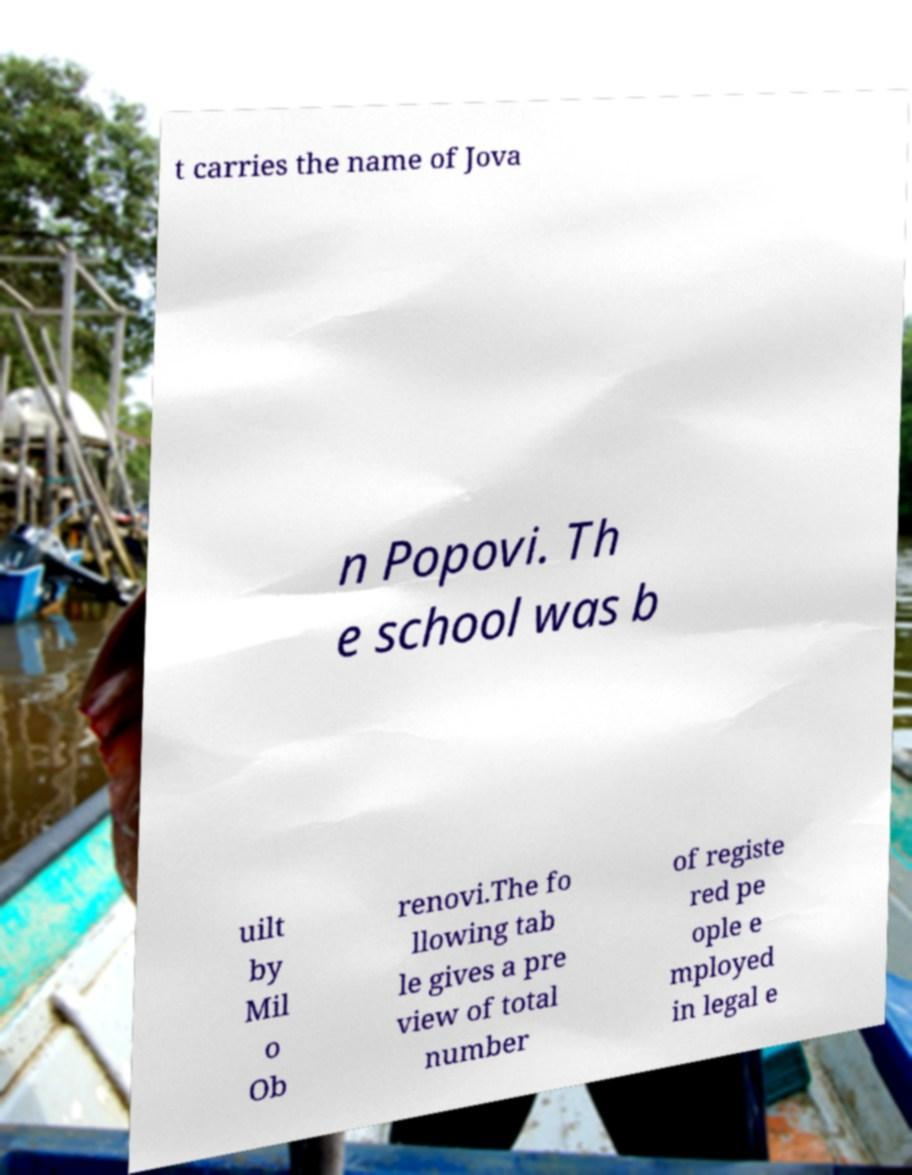I need the written content from this picture converted into text. Can you do that? t carries the name of Jova n Popovi. Th e school was b uilt by Mil o Ob renovi.The fo llowing tab le gives a pre view of total number of registe red pe ople e mployed in legal e 